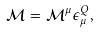<formula> <loc_0><loc_0><loc_500><loc_500>\mathcal { M } = \mathcal { M } ^ { \mu } \epsilon ^ { Q } _ { \mu } ,</formula> 